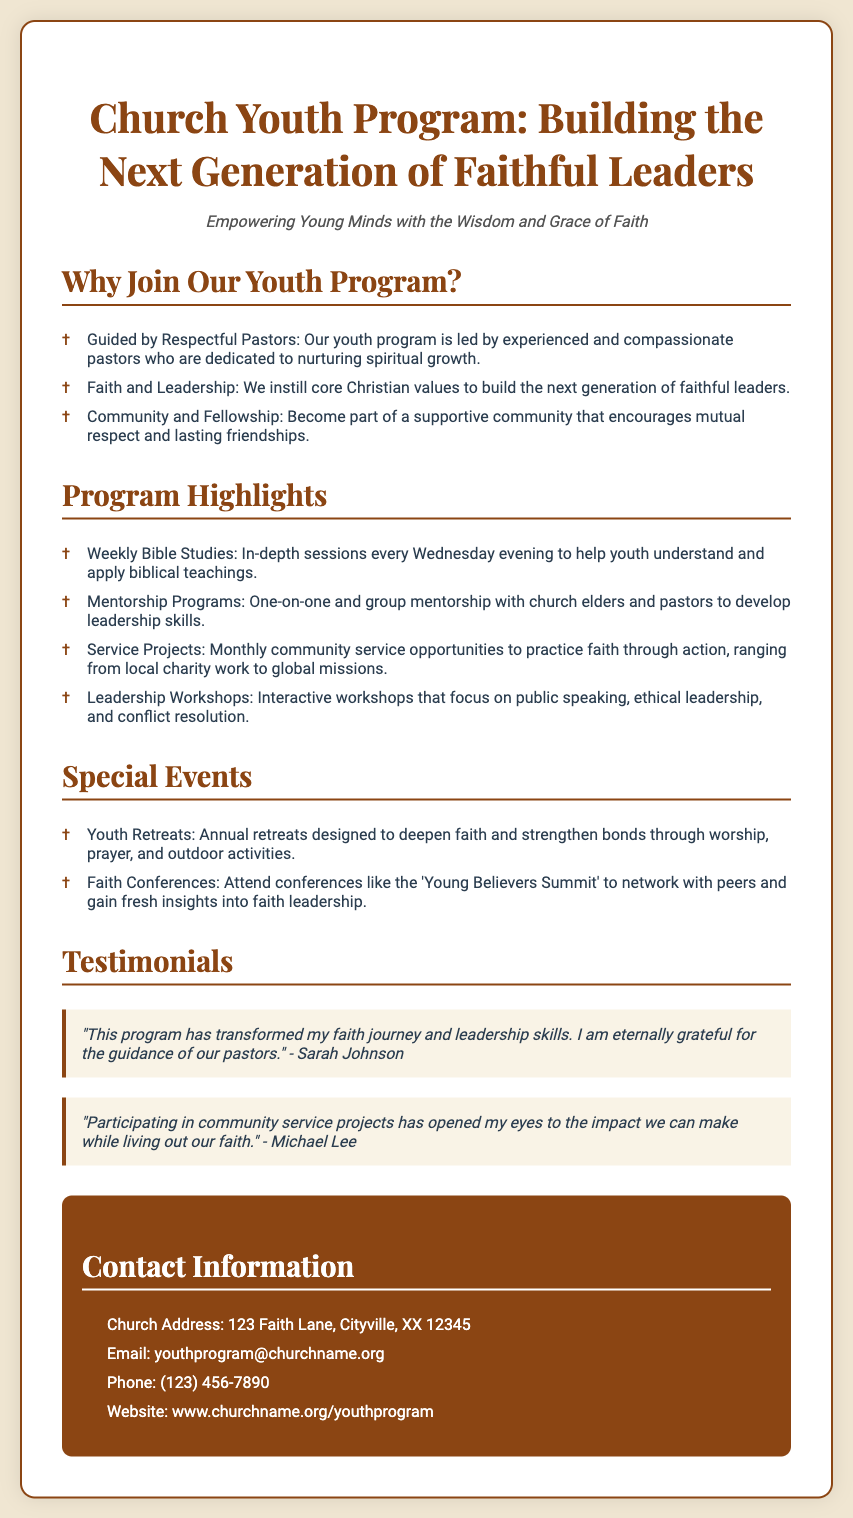What is the title of the program? The title of the program provides the name and focus of the initiative, which is "Church Youth Program: Building the Next Generation of Faithful Leaders."
Answer: Church Youth Program: Building the Next Generation of Faithful Leaders Who leads the youth program? This question asks for the role of the individuals in charge of the program, which are experienced and compassionate pastors.
Answer: Pastors What are the weekly Bible study sessions held? This is a straightforward query about when the Bible study sessions occur, which is indicated as every Wednesday evening.
Answer: Wednesday evening What is one of the special events mentioned? This question requires identifying a specific event highlighted in the document, where one such event is the annual retreats.
Answer: Youth Retreats What is the email contact for the youth program? The document includes a specific email address for contact which is provided in the contact information section.
Answer: youthprogram@churchname.org How many testimonials are featured in the flyer? This asks for the number of testimonials presented in the document, specifically mentioning that there are two testimonials shared.
Answer: Two What type of projects are included in the program highlights? The question is focused on the nature of specific activities mentioned, with community service projects being one of them.
Answer: Service Projects What is a main focus of the leadership workshops? The workshops aim to develop specific skills, with public speaking being one of the highlighted focuses.
Answer: Public speaking 